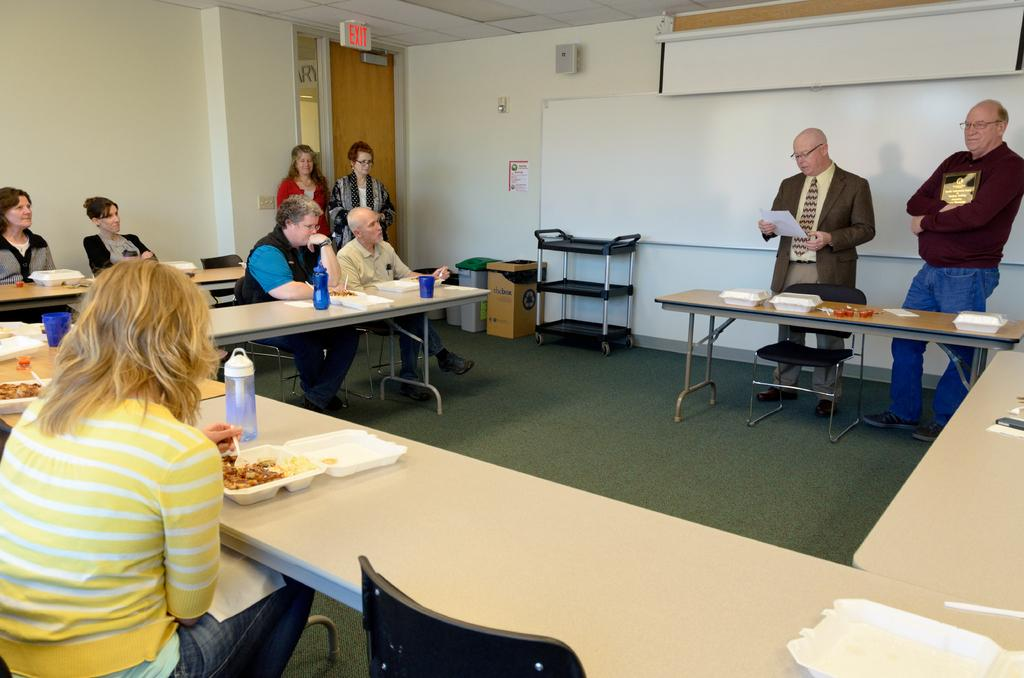How many people are in the image? There are several persons in the image. What are the persons doing in the image? The persons are sitting on chairs. What is in front of the chairs? There is a table in front of the chairs. What is on the table? There are plates on the table. What is on the wall in the image? There is a whiteboard on the wall. What type of room might this be? The setting appears to be a meeting room. Are there any pets visible in the image? No, there are no pets present in the image. What color is the zebra in the meeting room? There is no zebra present in the image, so it is not possible to determine its color. 